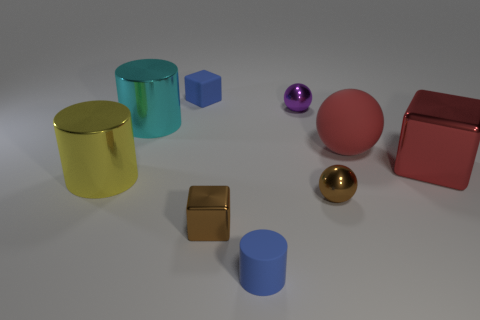Can you identify the shapes present in the image? Certainly! The shapes present include a cylinder, a cube, a sphere, and a box with a lid, which can also be classified as a cuboid. Does the lighting in the image suggest a particular time of day or source? The image appears to be artificially lit as opposed to natural lighting, which suggests there isn't a particular time of day represented. 